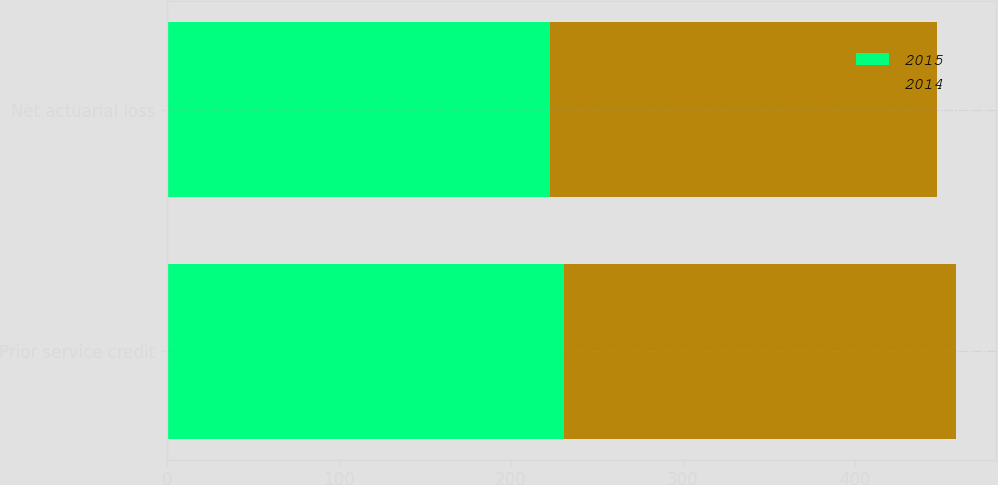Convert chart to OTSL. <chart><loc_0><loc_0><loc_500><loc_500><stacked_bar_chart><ecel><fcel>Prior service credit<fcel>Net actuarial loss<nl><fcel>2015<fcel>231<fcel>223<nl><fcel>2014<fcel>228<fcel>225<nl></chart> 